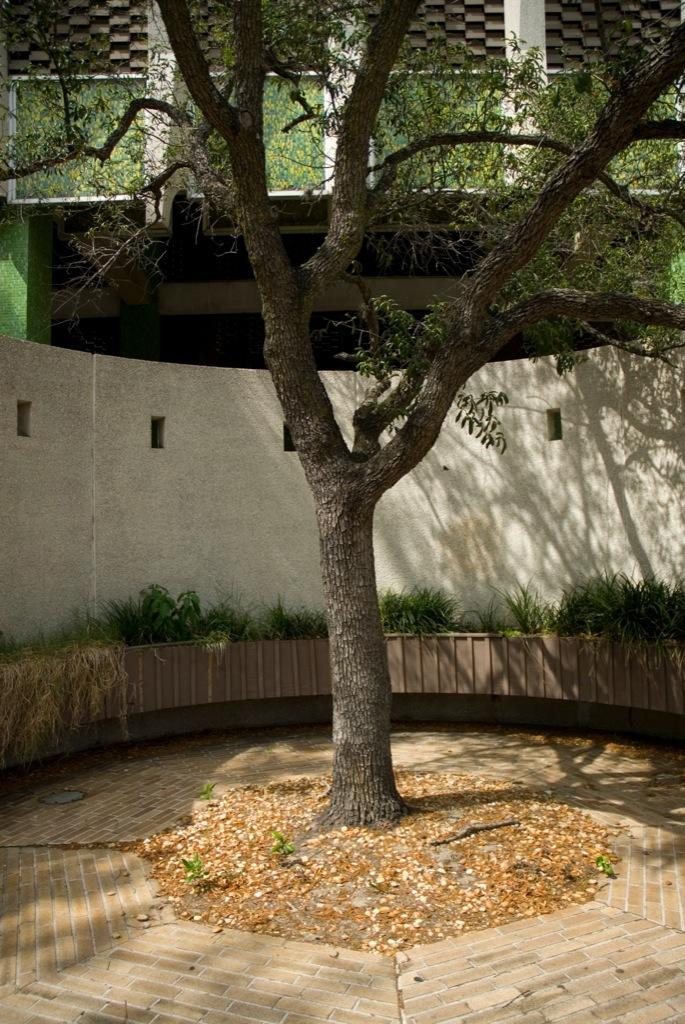What type of vegetation is present in the image? There is a tree and plants in the image. What is located behind the tree in the image? There is a wall behind the tree. What can be seen in the background of the image? There is a building in the background of the image. What is visible at the bottom of the image? The ground is visible at the bottom of the image. What type of agreement is being reached by the plants in the image? There are no agreements being made in the image, as plants do not have the ability to make agreements. What type of observation can be made about the writing on the wall in the image? There is no writing on the wall in the image. 